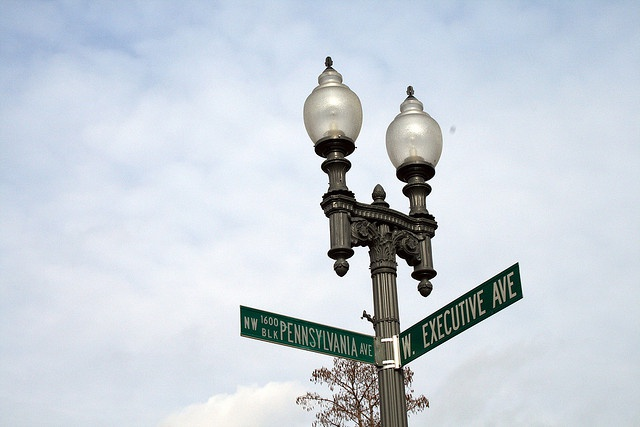Describe the objects in this image and their specific colors. I can see various objects in this image with different colors. 